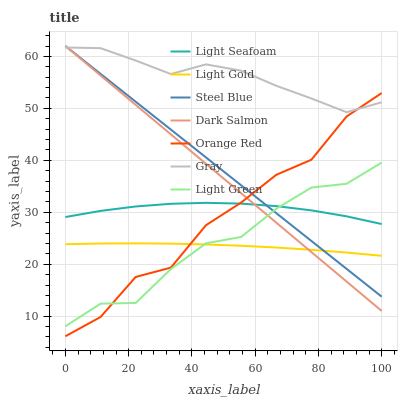Does Light Gold have the minimum area under the curve?
Answer yes or no. Yes. Does Gray have the maximum area under the curve?
Answer yes or no. Yes. Does Steel Blue have the minimum area under the curve?
Answer yes or no. No. Does Steel Blue have the maximum area under the curve?
Answer yes or no. No. Is Dark Salmon the smoothest?
Answer yes or no. Yes. Is Orange Red the roughest?
Answer yes or no. Yes. Is Steel Blue the smoothest?
Answer yes or no. No. Is Steel Blue the roughest?
Answer yes or no. No. Does Orange Red have the lowest value?
Answer yes or no. Yes. Does Steel Blue have the lowest value?
Answer yes or no. No. Does Dark Salmon have the highest value?
Answer yes or no. Yes. Does Light Green have the highest value?
Answer yes or no. No. Is Light Gold less than Light Seafoam?
Answer yes or no. Yes. Is Gray greater than Light Green?
Answer yes or no. Yes. Does Light Gold intersect Light Green?
Answer yes or no. Yes. Is Light Gold less than Light Green?
Answer yes or no. No. Is Light Gold greater than Light Green?
Answer yes or no. No. Does Light Gold intersect Light Seafoam?
Answer yes or no. No. 